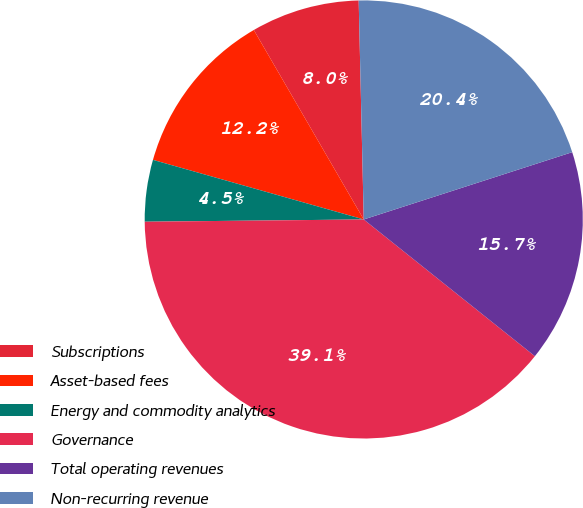Convert chart. <chart><loc_0><loc_0><loc_500><loc_500><pie_chart><fcel>Subscriptions<fcel>Asset-based fees<fcel>Energy and commodity analytics<fcel>Governance<fcel>Total operating revenues<fcel>Non-recurring revenue<nl><fcel>8.0%<fcel>12.25%<fcel>4.55%<fcel>39.11%<fcel>15.7%<fcel>20.4%<nl></chart> 